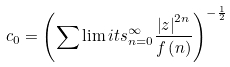Convert formula to latex. <formula><loc_0><loc_0><loc_500><loc_500>c _ { 0 } = \left ( \sum \lim i t s _ { n = 0 } ^ { \infty } \frac { \left | z \right | ^ { 2 n } } { f \left ( n \right ) } \right ) ^ { - \frac { 1 } { 2 } }</formula> 